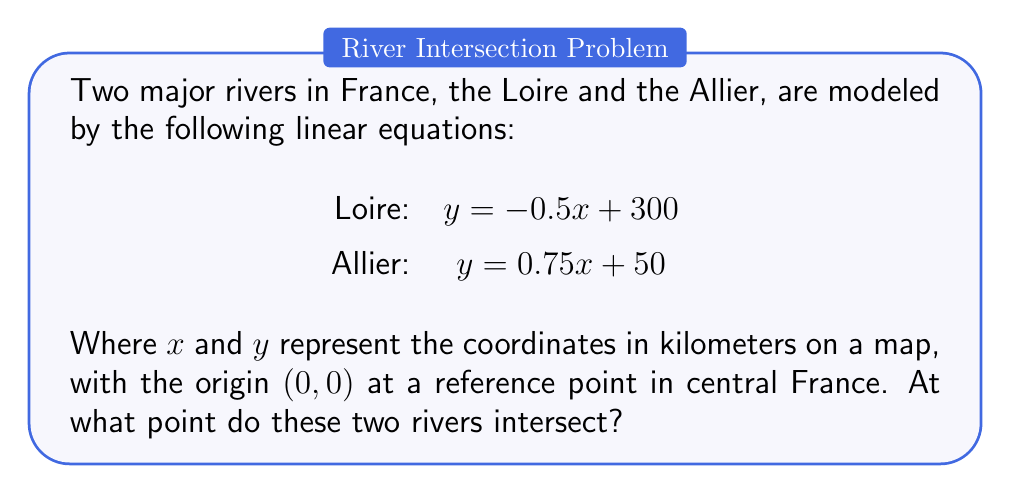Can you answer this question? To find the intersection point of these two rivers, we need to solve the system of equations:

$$\begin{cases}
y = -0.5x + 300 \\
y = 0.75x + 50
\end{cases}$$

1) First, let's set the two equations equal to each other:

   $-0.5x + 300 = 0.75x + 50$

2) Now, we'll solve for $x$:
   
   $-0.5x - 0.75x = 50 - 300$
   $-1.25x = -250$
   $x = 200$

3) Now that we know $x$, we can substitute it into either of the original equations to find $y$. Let's use the Loire equation:

   $y = -0.5(200) + 300$
   $y = -100 + 300$
   $y = 200$

4) Therefore, the intersection point is (200, 200).

This means the Loire and the Allier intersect at a point 200 km east and 200 km north of our reference point in central France.
Answer: The rivers intersect at the point (200, 200). 